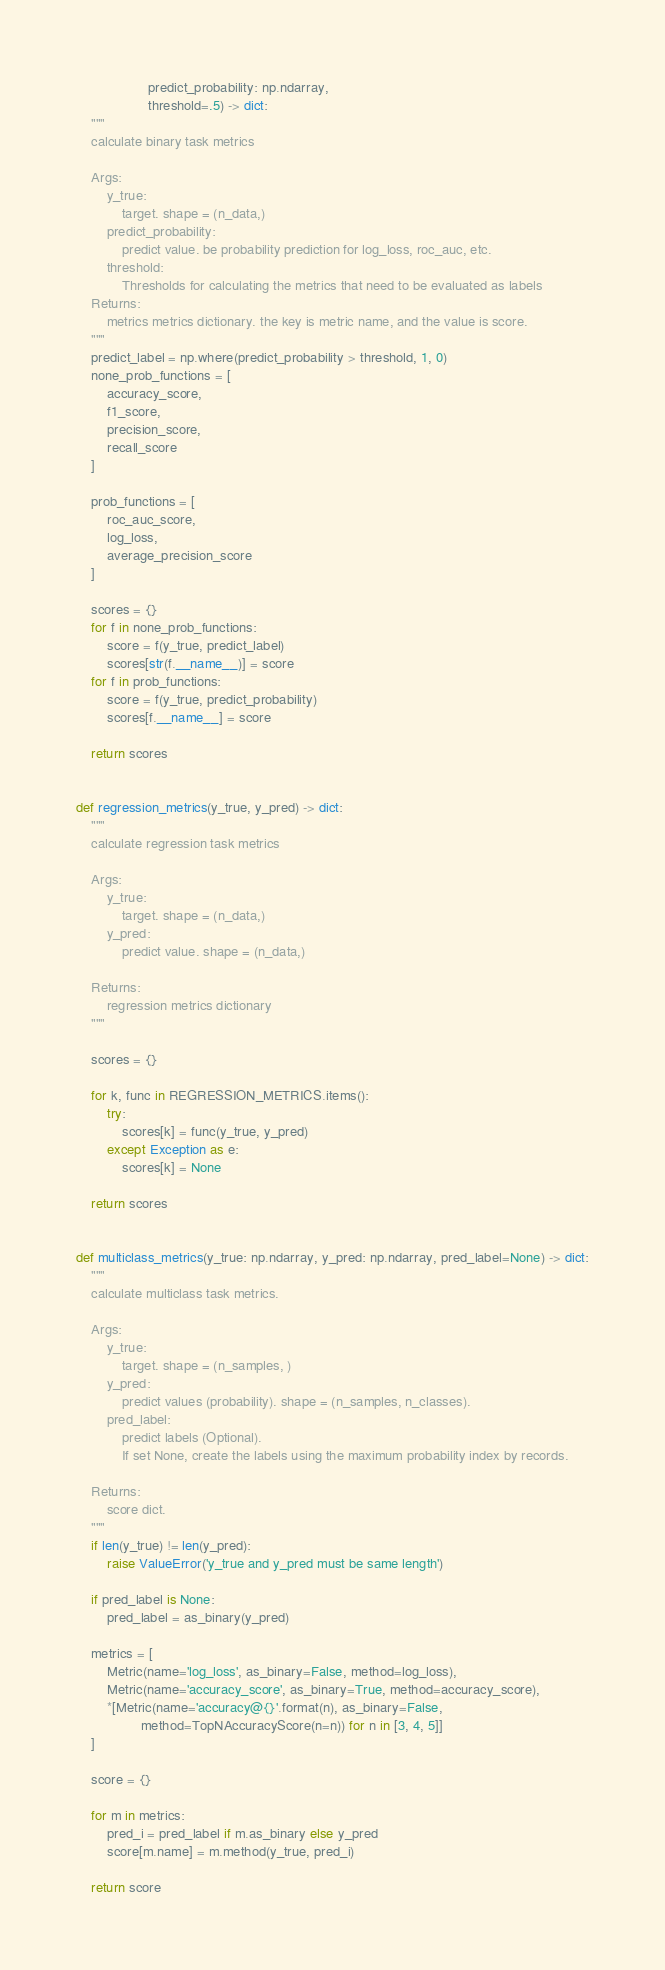<code> <loc_0><loc_0><loc_500><loc_500><_Python_>                   predict_probability: np.ndarray,
                   threshold=.5) -> dict:
    """
    calculate binary task metrics

    Args:
        y_true:
            target. shape = (n_data,)
        predict_probability:
            predict value. be probability prediction for log_loss, roc_auc, etc.
        threshold:
            Thresholds for calculating the metrics that need to be evaluated as labels
    Returns:
        metrics metrics dictionary. the key is metric name, and the value is score.
    """
    predict_label = np.where(predict_probability > threshold, 1, 0)
    none_prob_functions = [
        accuracy_score,
        f1_score,
        precision_score,
        recall_score
    ]

    prob_functions = [
        roc_auc_score,
        log_loss,
        average_precision_score
    ]

    scores = {}
    for f in none_prob_functions:
        score = f(y_true, predict_label)
        scores[str(f.__name__)] = score
    for f in prob_functions:
        score = f(y_true, predict_probability)
        scores[f.__name__] = score

    return scores


def regression_metrics(y_true, y_pred) -> dict:
    """
    calculate regression task metrics

    Args:
        y_true:
            target. shape = (n_data,)
        y_pred:
            predict value. shape = (n_data,)

    Returns:
        regression metrics dictionary
    """

    scores = {}

    for k, func in REGRESSION_METRICS.items():
        try:
            scores[k] = func(y_true, y_pred)
        except Exception as e:
            scores[k] = None

    return scores


def multiclass_metrics(y_true: np.ndarray, y_pred: np.ndarray, pred_label=None) -> dict:
    """
    calculate multiclass task metrics.

    Args:
        y_true:
            target. shape = (n_samples, )
        y_pred:
            predict values (probability). shape = (n_samples, n_classes).
        pred_label:
            predict labels (Optional).
            If set None, create the labels using the maximum probability index by records.

    Returns:
        score dict.
    """
    if len(y_true) != len(y_pred):
        raise ValueError('y_true and y_pred must be same length')

    if pred_label is None:
        pred_label = as_binary(y_pred)

    metrics = [
        Metric(name='log_loss', as_binary=False, method=log_loss),
        Metric(name='accuracy_score', as_binary=True, method=accuracy_score),
        *[Metric(name='accuracy@{}'.format(n), as_binary=False,
                 method=TopNAccuracyScore(n=n)) for n in [3, 4, 5]]
    ]

    score = {}

    for m in metrics:
        pred_i = pred_label if m.as_binary else y_pred
        score[m.name] = m.method(y_true, pred_i)

    return score
</code> 